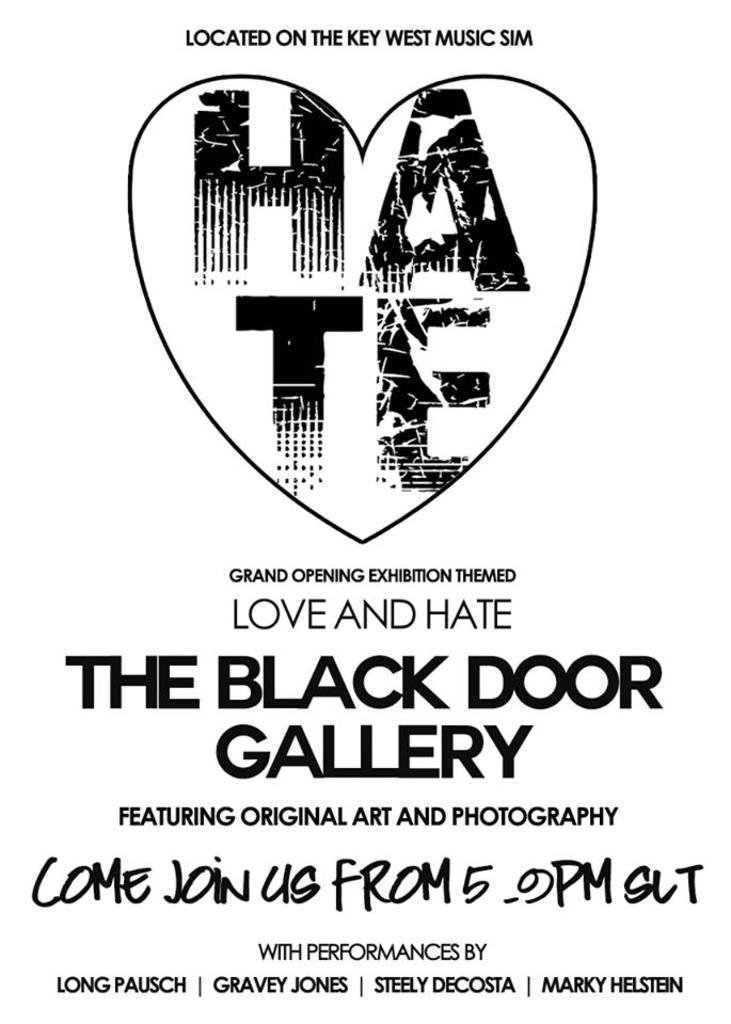<image>
Relay a brief, clear account of the picture shown. A poster for Love and Hate exhibition between 5 and 9 pm 